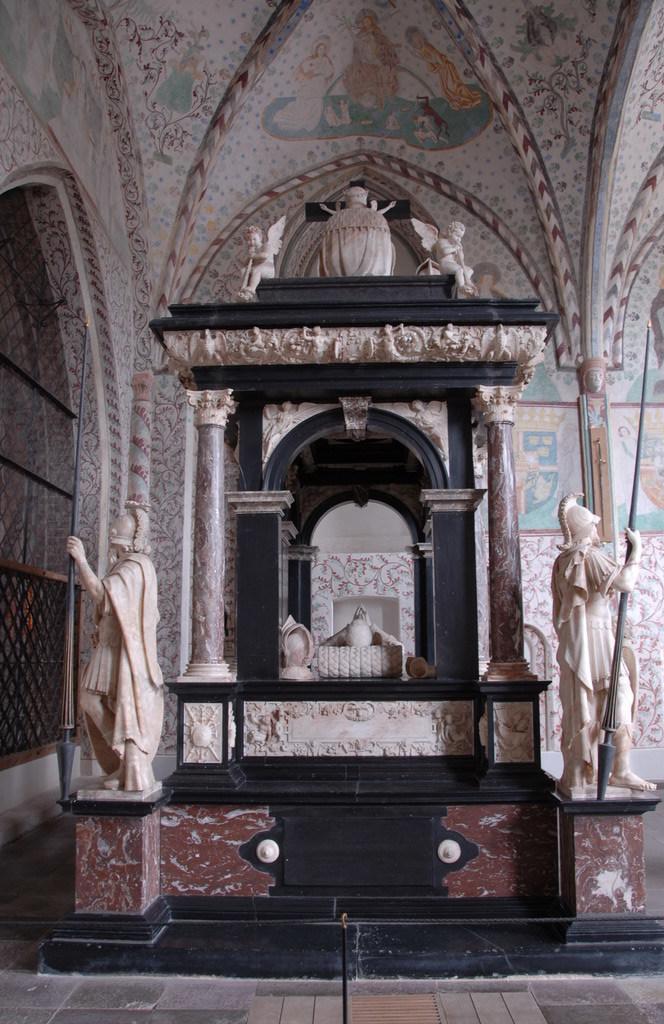Describe this image in one or two sentences. In this picture we can see an inside view of a building, on the right side and left side there are two statues, in the background there is a wall. 